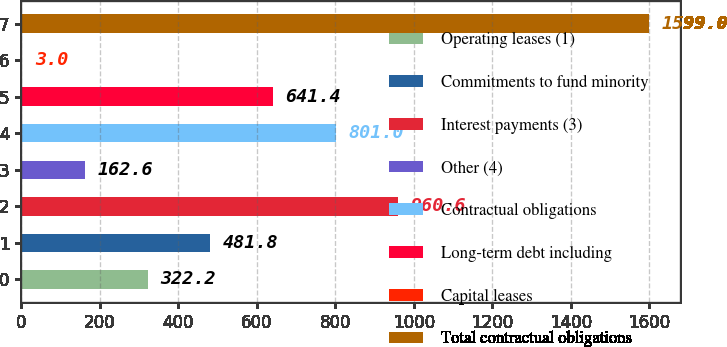<chart> <loc_0><loc_0><loc_500><loc_500><bar_chart><fcel>Operating leases (1)<fcel>Commitments to fund minority<fcel>Interest payments (3)<fcel>Other (4)<fcel>Contractual obligations<fcel>Long-term debt including<fcel>Capital leases<fcel>Total contractual obligations<nl><fcel>322.2<fcel>481.8<fcel>960.6<fcel>162.6<fcel>801<fcel>641.4<fcel>3<fcel>1599<nl></chart> 